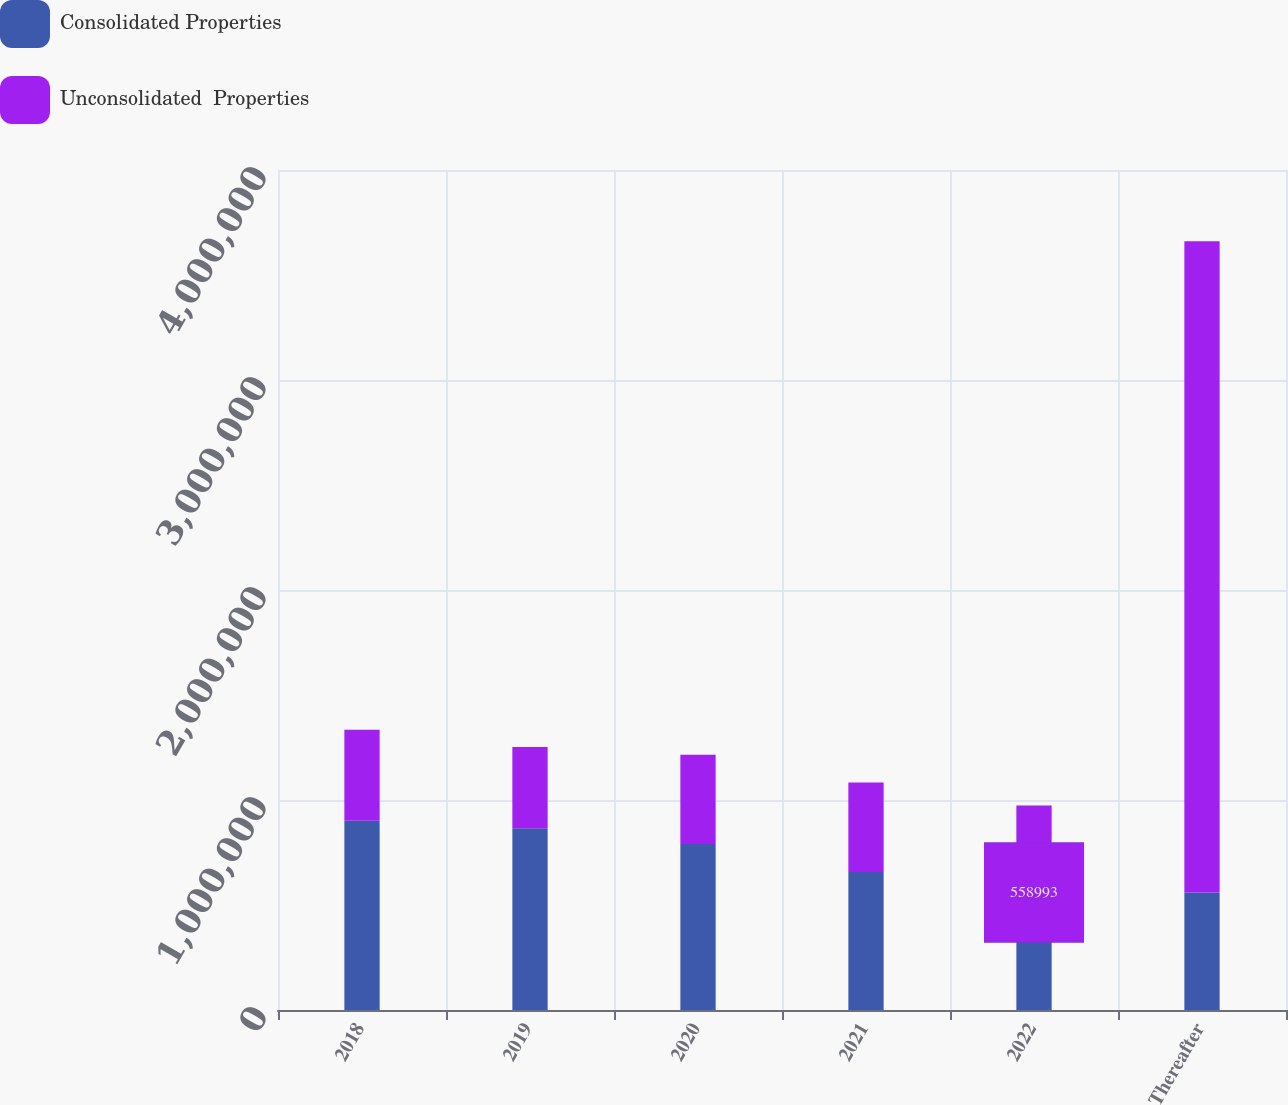<chart> <loc_0><loc_0><loc_500><loc_500><stacked_bar_chart><ecel><fcel>2018<fcel>2019<fcel>2020<fcel>2021<fcel>2022<fcel>Thereafter<nl><fcel>Consolidated Properties<fcel>901092<fcel>865254<fcel>790714<fcel>657283<fcel>558993<fcel>558993<nl><fcel>Unconsolidated  Properties<fcel>433764<fcel>386564<fcel>424201<fcel>426078<fcel>414889<fcel>3.10231e+06<nl></chart> 